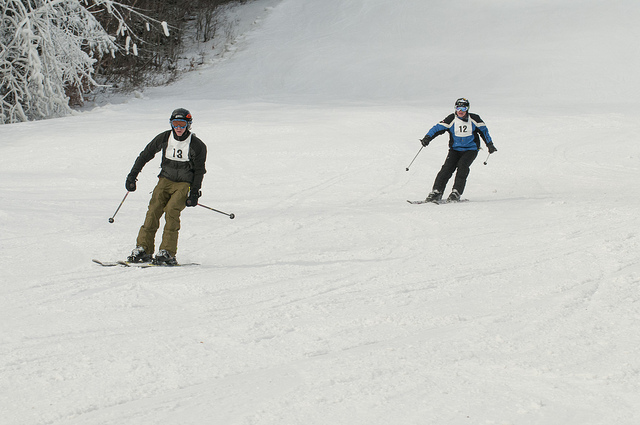Identify and read out the text in this image. 13 12 